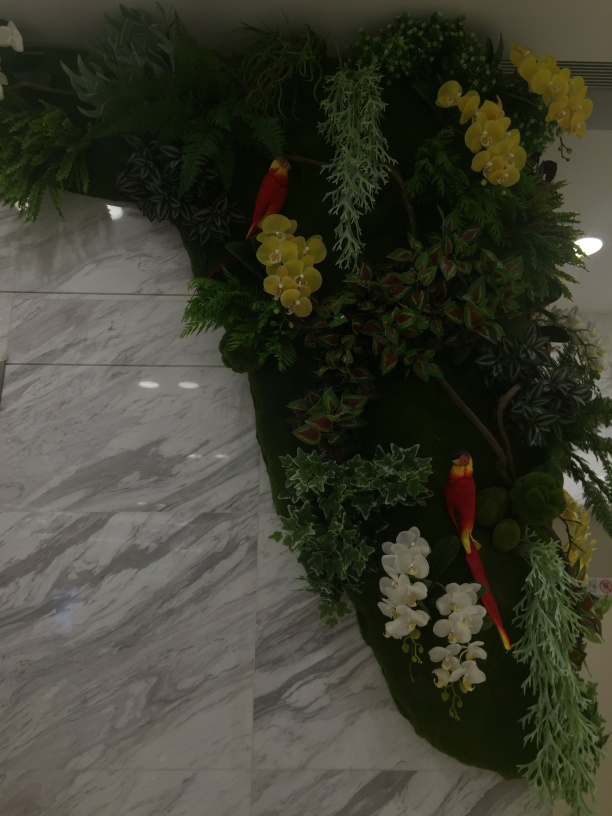Please describe the atmosphere that this arrangement of flowers and greens creates in the space. The arrangement of bright, lush flowers interspersed with various shades of greenery brings a sense of vibrancy and natural freshness to the space. It contributes to an atmosphere that is tranquil yet lively, reminiscent of a tropical garden that stimulates a feeling of comfort and calmness. 